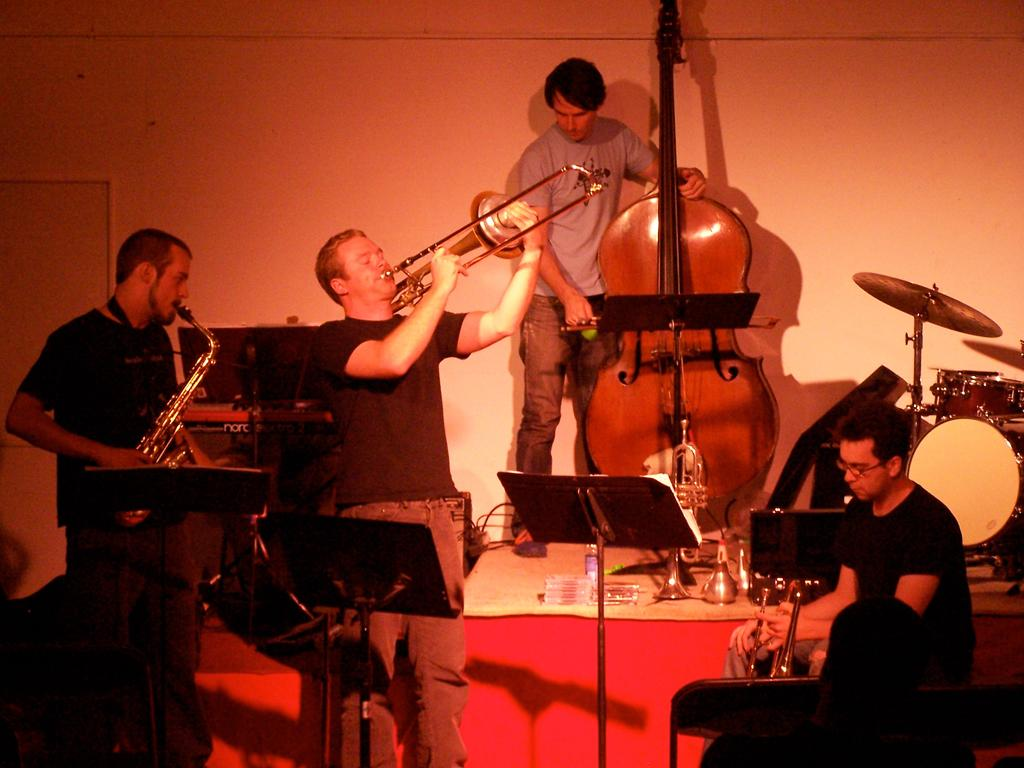What are the men in the image doing? The men in the image are holding musical instruments. What else can be seen in the image besides the men? There is a book stand visible in the image. What type of structure is present in the image? There are walls visible in the image. What type of coil is being used by the men to create music in the image? There is no coil present in the image, and the men are not using any coils to create music. Can you tell me who the partner of the man on the left is in the image? There is no partner mentioned or visible in the image. 